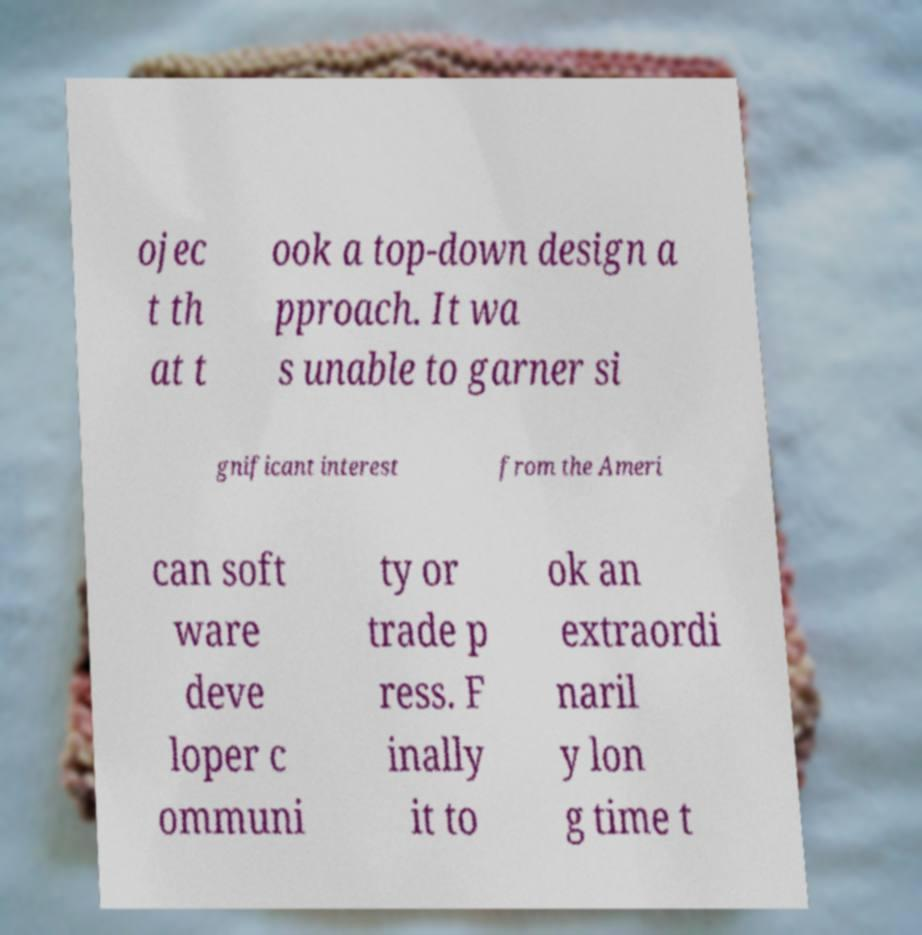Can you read and provide the text displayed in the image?This photo seems to have some interesting text. Can you extract and type it out for me? ojec t th at t ook a top-down design a pproach. It wa s unable to garner si gnificant interest from the Ameri can soft ware deve loper c ommuni ty or trade p ress. F inally it to ok an extraordi naril y lon g time t 